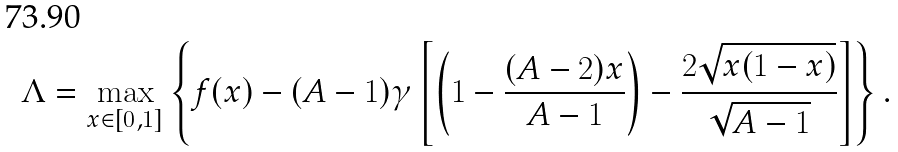Convert formula to latex. <formula><loc_0><loc_0><loc_500><loc_500>\Lambda = \max _ { x \in [ 0 , 1 ] } \left \{ f ( x ) - ( A - 1 ) \gamma \left [ \left ( 1 - \frac { ( A - 2 ) x } { A - 1 } \right ) - \frac { 2 \sqrt { x ( 1 - x ) } } { \sqrt { A - 1 } } \right ] \right \} .</formula> 